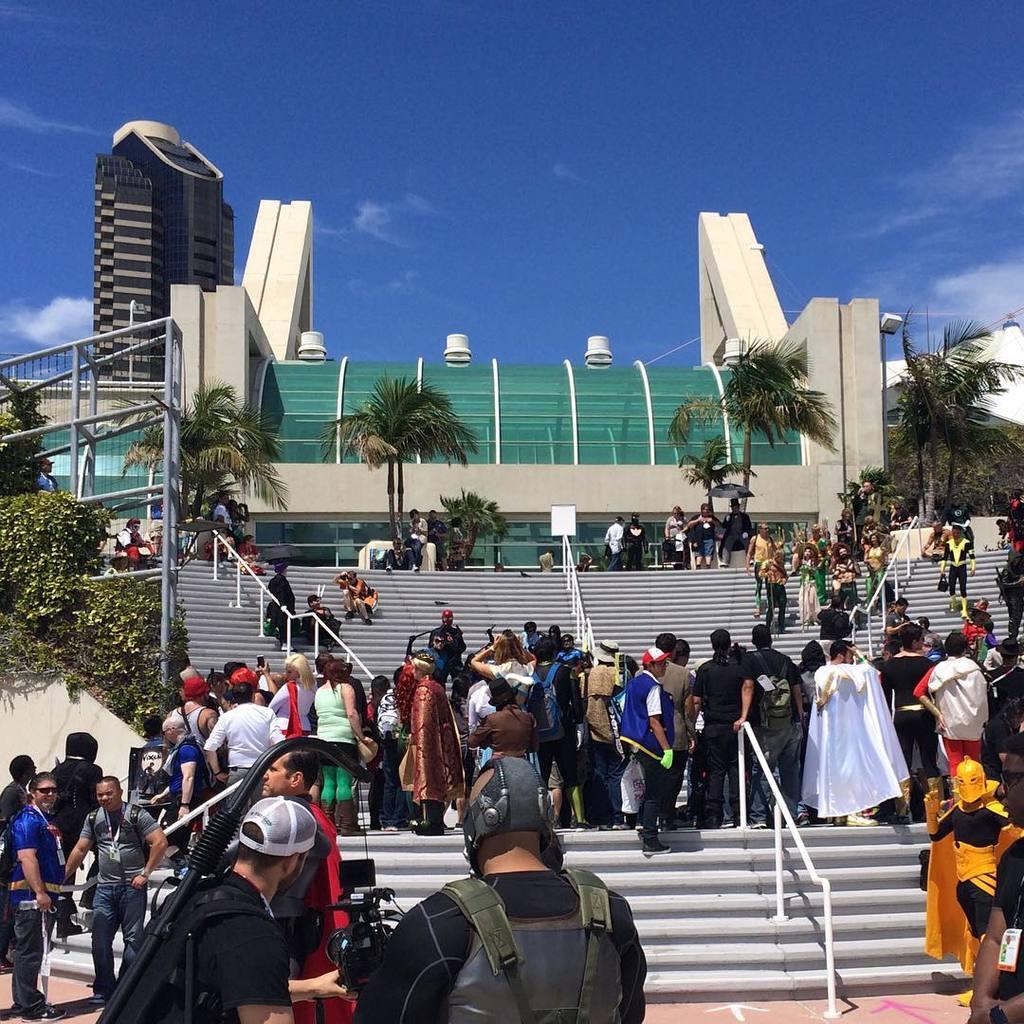In one or two sentences, can you explain what this image depicts? In this image we can see building, trees, persons sitting on the benches, persons standing on the floor, persons standing on the stairs, railings and sky with clouds. 